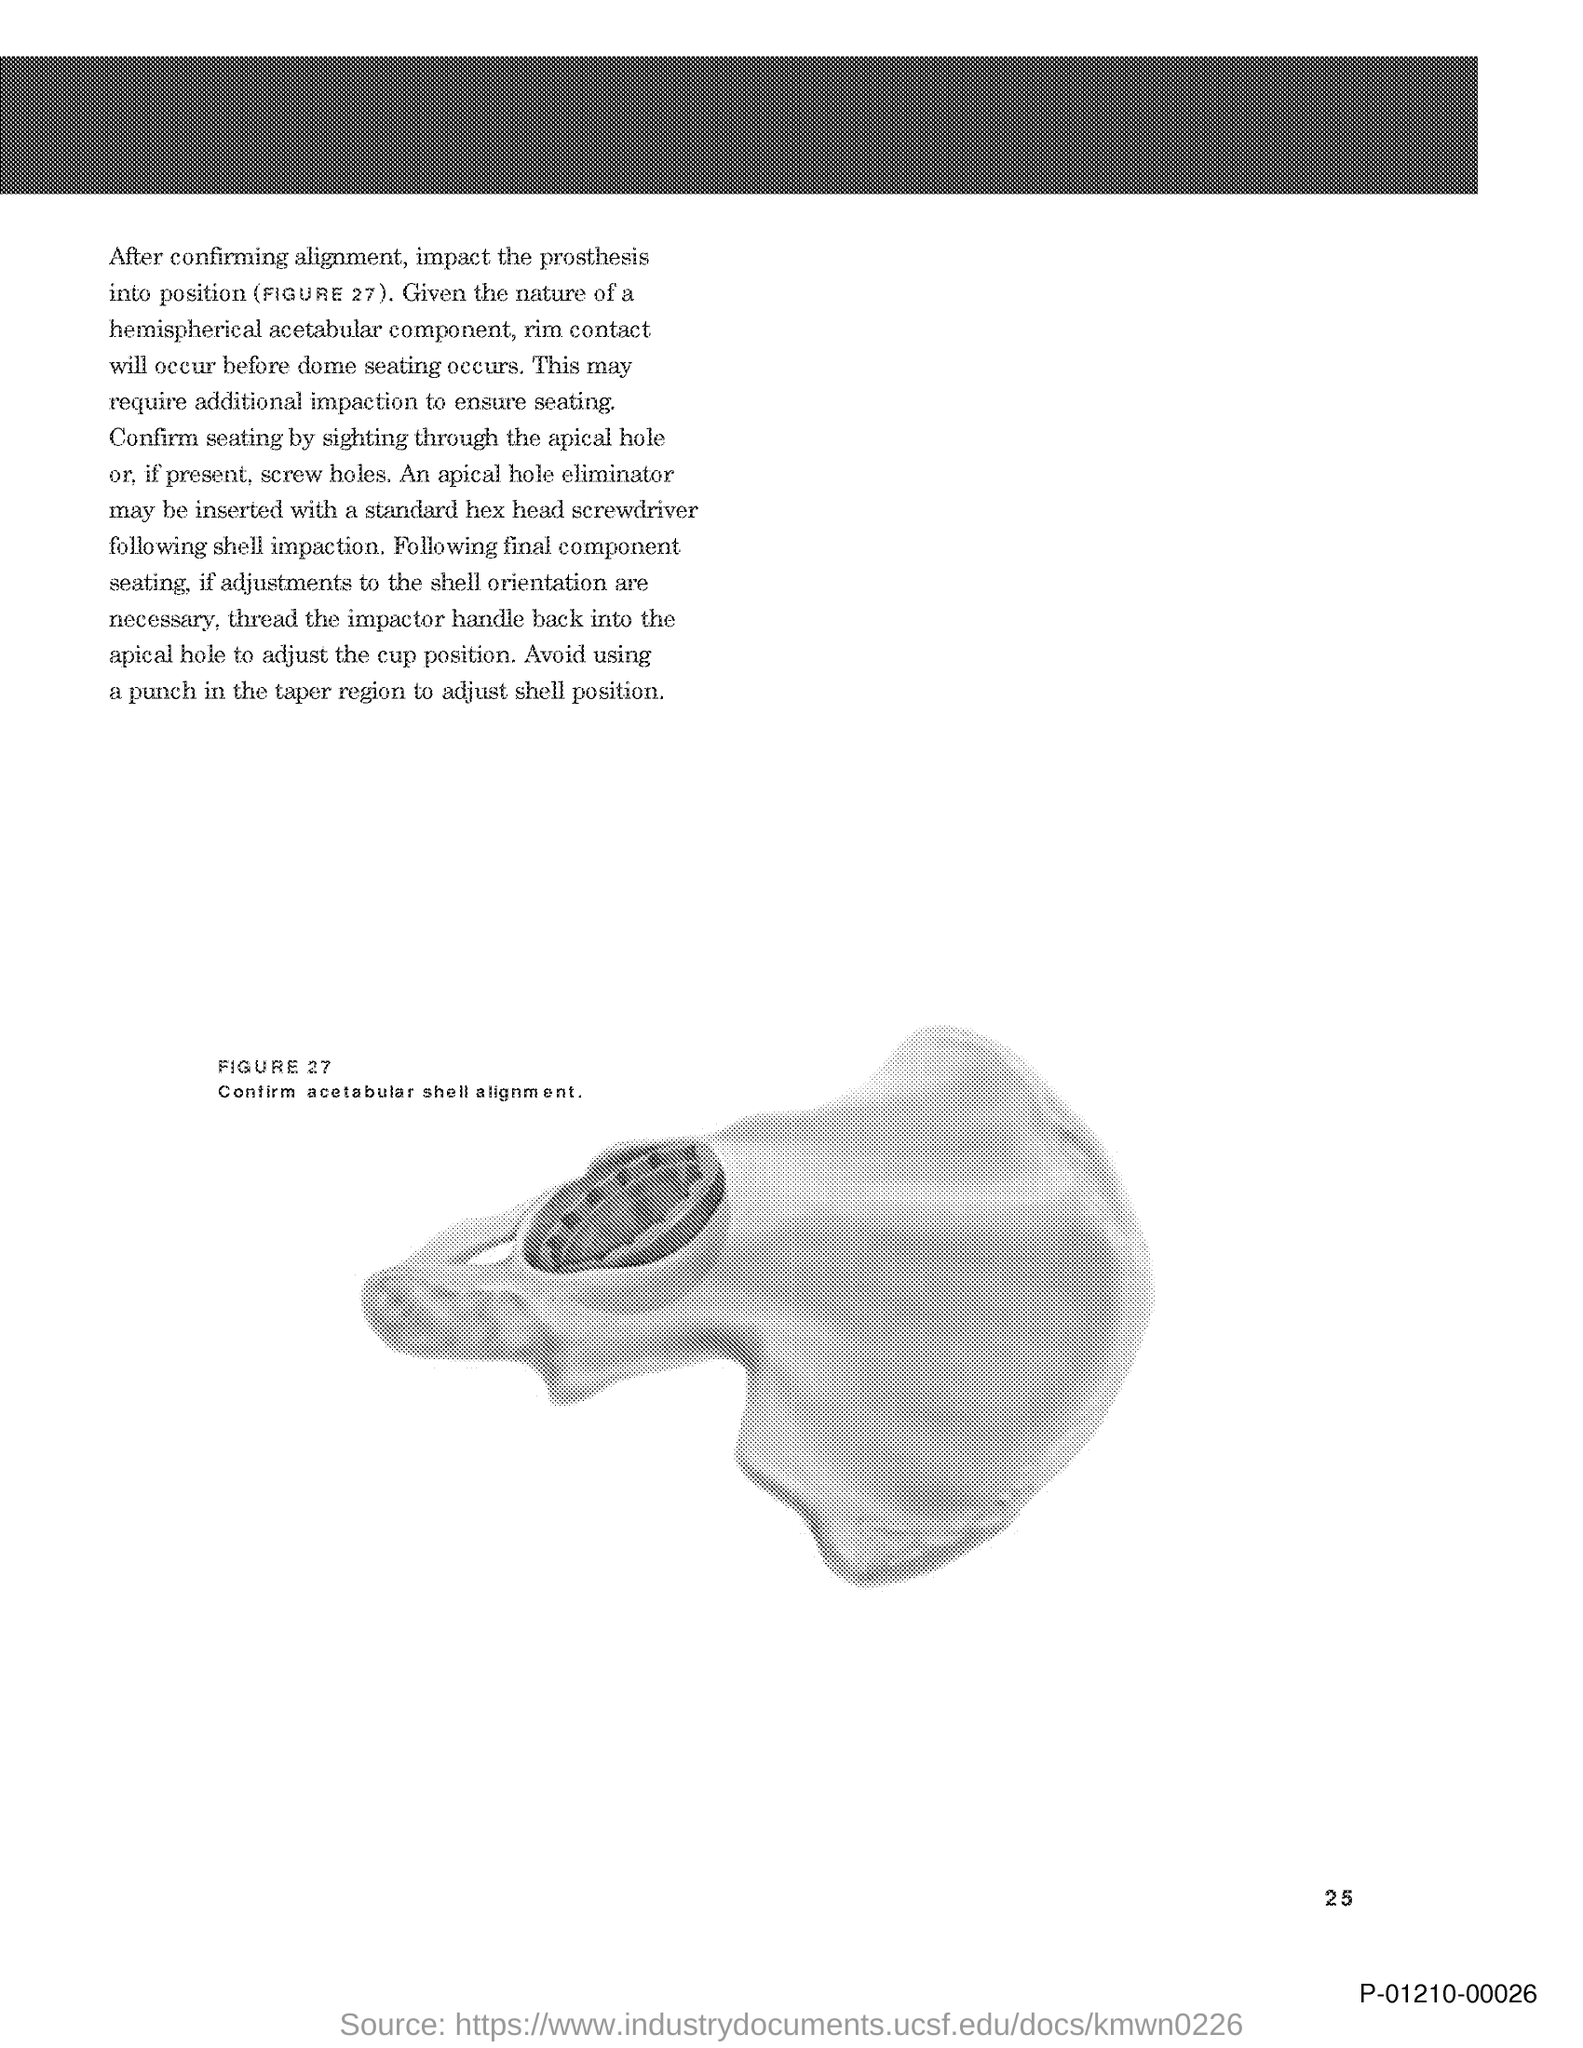Identify some key points in this picture. The figure represents the acetabular shell alignment, which must be confirmed for proper surgical planning. It is advisable to refrain from using a punch in the taper region of a bolt to adjust the position of a shell, as this can lead to issues with accuracy and stability. 